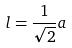<formula> <loc_0><loc_0><loc_500><loc_500>l = \frac { 1 } { \sqrt { 2 } } a</formula> 